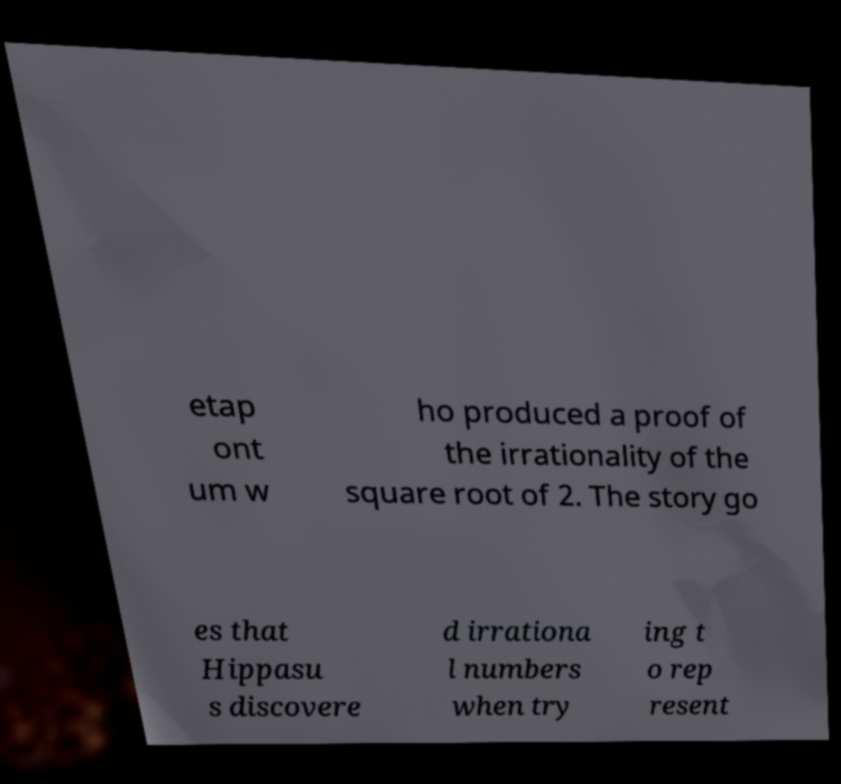Can you accurately transcribe the text from the provided image for me? etap ont um w ho produced a proof of the irrationality of the square root of 2. The story go es that Hippasu s discovere d irrationa l numbers when try ing t o rep resent 